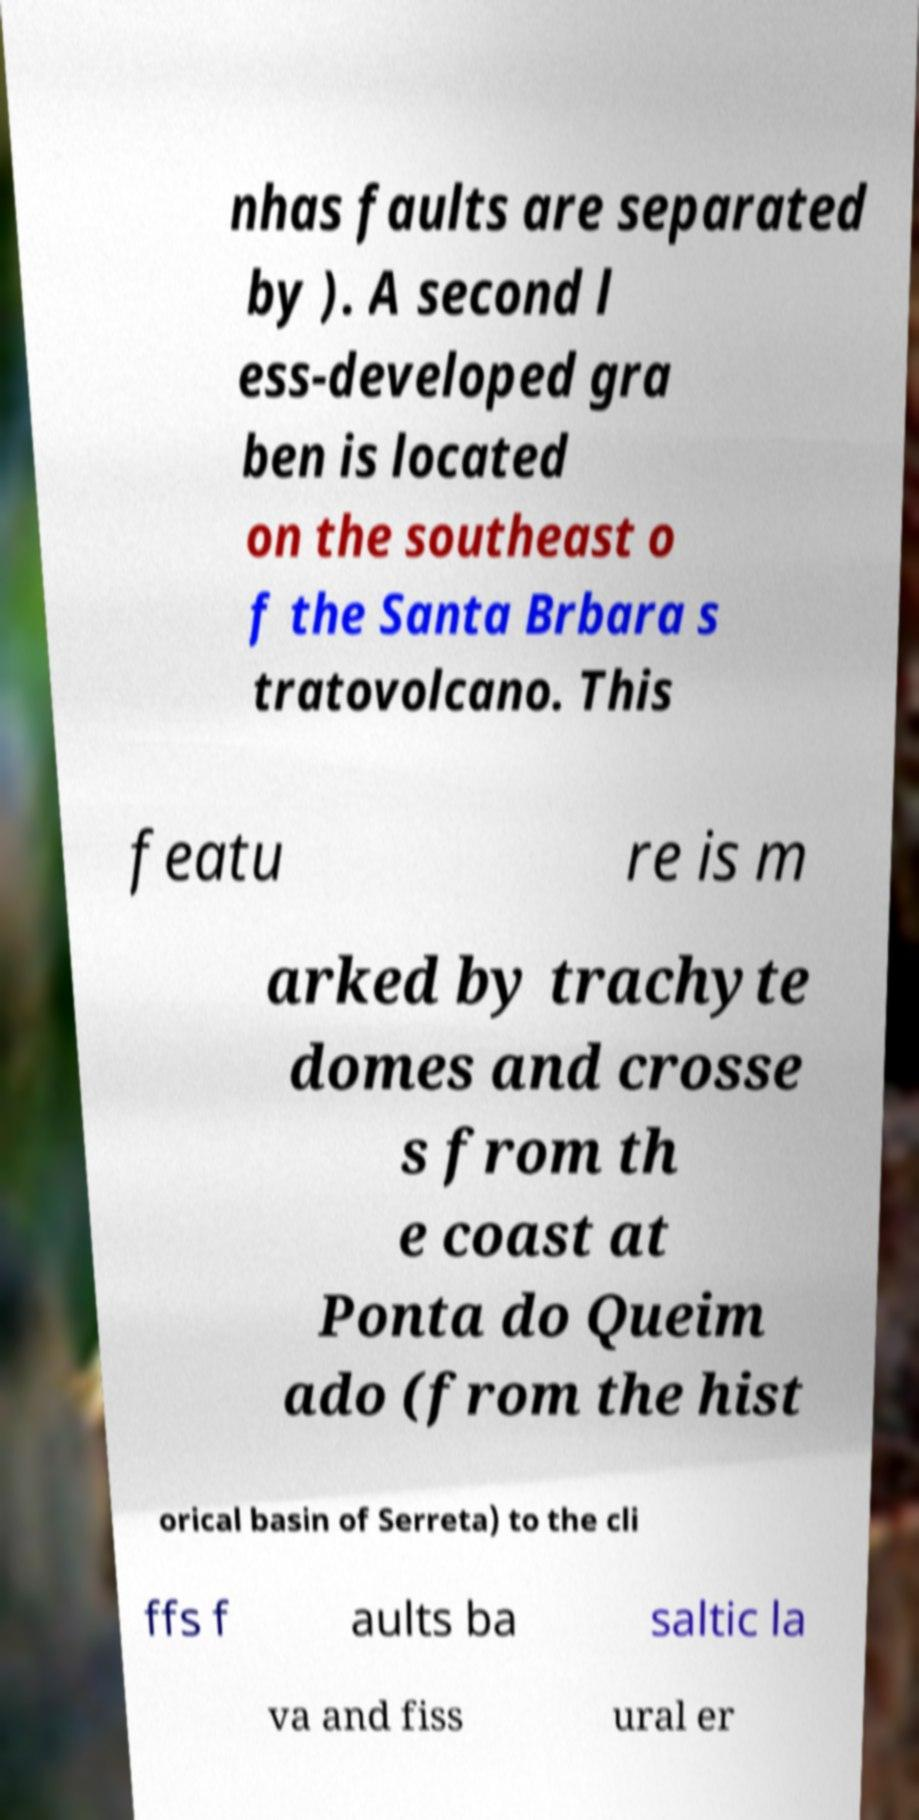Could you extract and type out the text from this image? nhas faults are separated by ). A second l ess-developed gra ben is located on the southeast o f the Santa Brbara s tratovolcano. This featu re is m arked by trachyte domes and crosse s from th e coast at Ponta do Queim ado (from the hist orical basin of Serreta) to the cli ffs f aults ba saltic la va and fiss ural er 